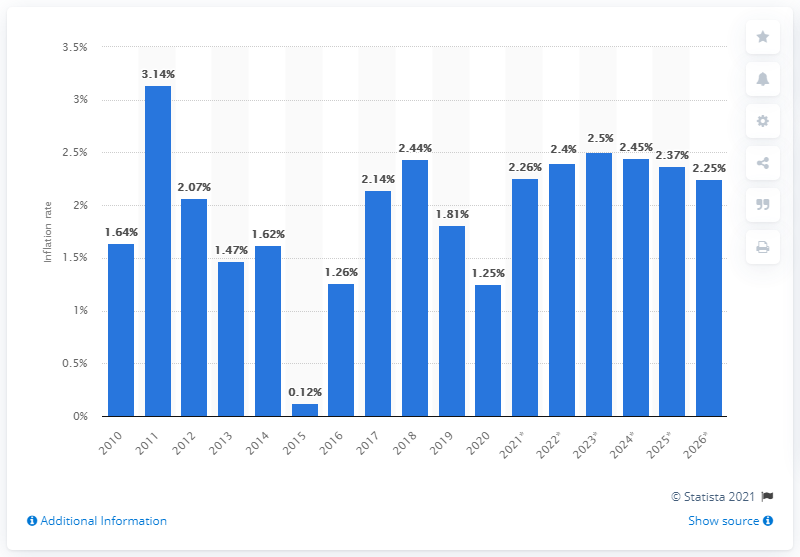Mention a couple of crucial points in this snapshot. The forecast predicts that prices will increase by 2.25% in 2021. 